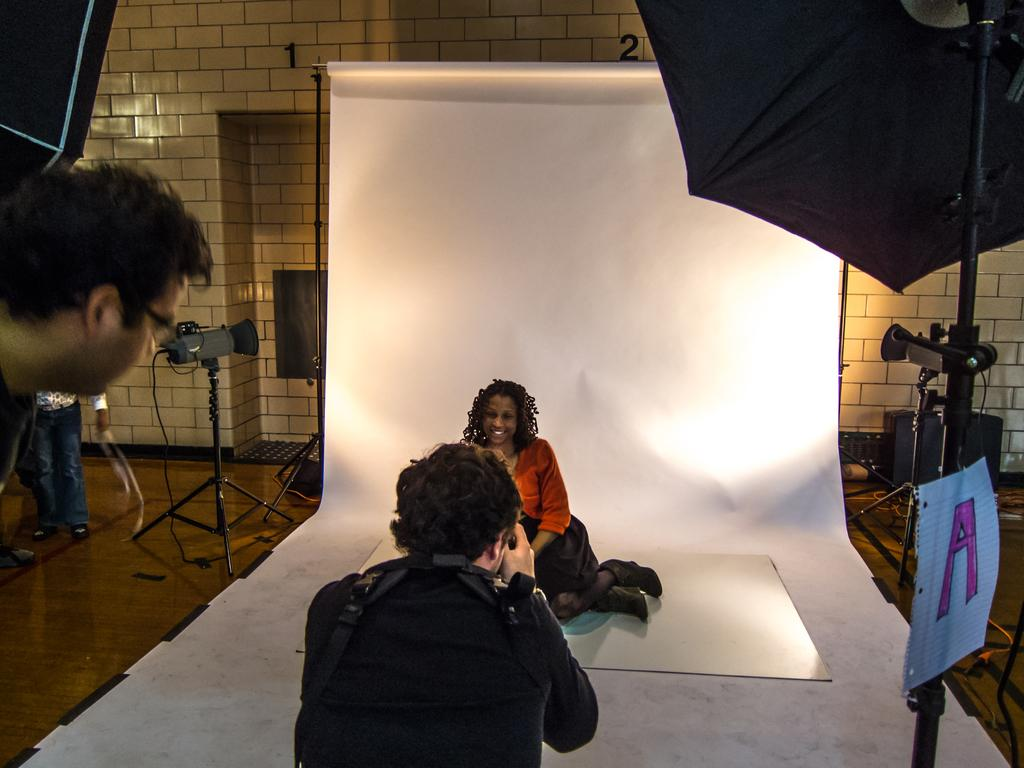What is the woman in the image doing? The woman is giving a pose for a photo in the image. Who else is present in the image? There is a camera man in the image. What equipment is visible in the image? Camera stands and lights are present in the image. What can be seen in the background of the image? There is a white banner in the image. What type of elbow is being used to hold the banner in the image? There is no elbow present in the image, nor is there any mention of a banner being held. 